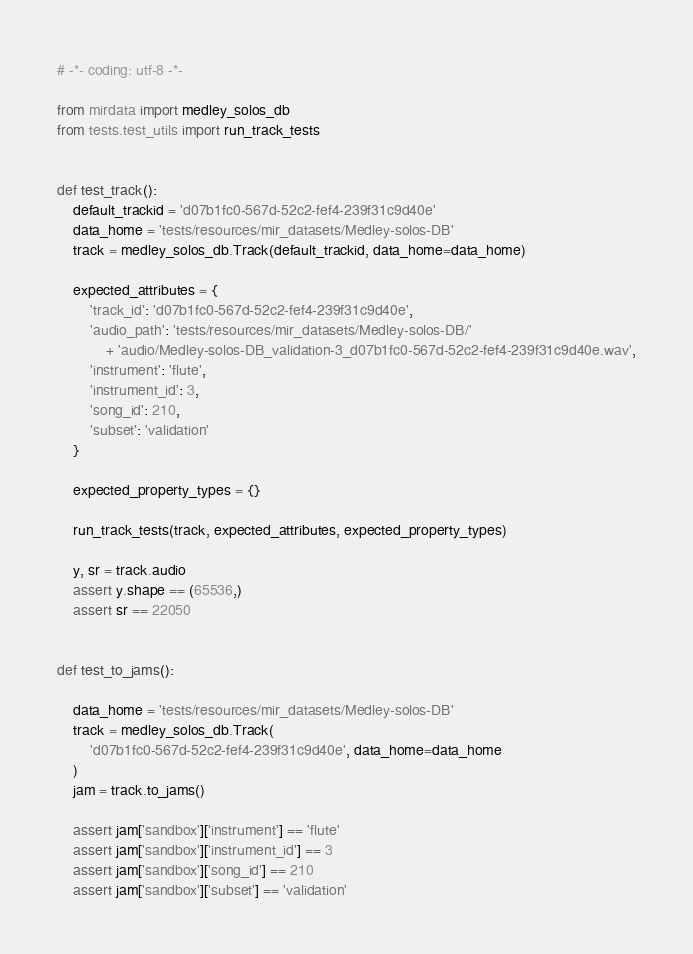<code> <loc_0><loc_0><loc_500><loc_500><_Python_># -*- coding: utf-8 -*-

from mirdata import medley_solos_db
from tests.test_utils import run_track_tests


def test_track():
    default_trackid = 'd07b1fc0-567d-52c2-fef4-239f31c9d40e'
    data_home = 'tests/resources/mir_datasets/Medley-solos-DB'
    track = medley_solos_db.Track(default_trackid, data_home=data_home)

    expected_attributes = {
        'track_id': 'd07b1fc0-567d-52c2-fef4-239f31c9d40e',
        'audio_path': 'tests/resources/mir_datasets/Medley-solos-DB/'
            + 'audio/Medley-solos-DB_validation-3_d07b1fc0-567d-52c2-fef4-239f31c9d40e.wav',
        'instrument': 'flute',
        'instrument_id': 3,
        'song_id': 210,
        'subset': 'validation'
    }

    expected_property_types = {}

    run_track_tests(track, expected_attributes, expected_property_types)

    y, sr = track.audio
    assert y.shape == (65536,)
    assert sr == 22050


def test_to_jams():

    data_home = 'tests/resources/mir_datasets/Medley-solos-DB'
    track = medley_solos_db.Track(
        'd07b1fc0-567d-52c2-fef4-239f31c9d40e', data_home=data_home
    )
    jam = track.to_jams()

    assert jam['sandbox']['instrument'] == 'flute'
    assert jam['sandbox']['instrument_id'] == 3
    assert jam['sandbox']['song_id'] == 210
    assert jam['sandbox']['subset'] == 'validation'
</code> 